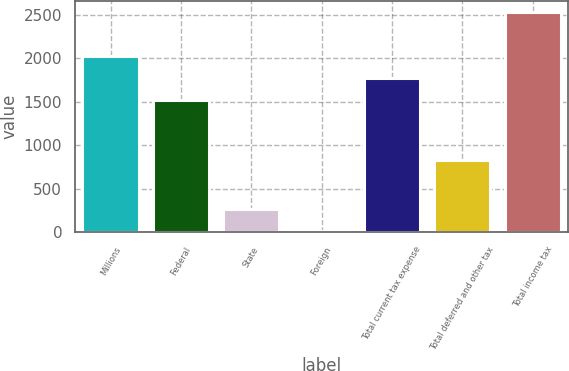<chart> <loc_0><loc_0><loc_500><loc_500><bar_chart><fcel>Millions<fcel>Federal<fcel>State<fcel>Foreign<fcel>Total current tax expense<fcel>Total deferred and other tax<fcel>Total income tax<nl><fcel>2023<fcel>1518<fcel>260.5<fcel>8<fcel>1770.5<fcel>831<fcel>2533<nl></chart> 